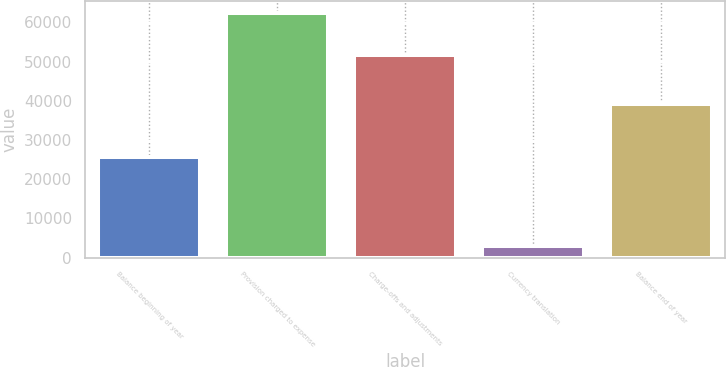Convert chart to OTSL. <chart><loc_0><loc_0><loc_500><loc_500><bar_chart><fcel>Balance beginning of year<fcel>Provision charged to expense<fcel>Charge-offs and adjustments<fcel>Currency translation<fcel>Balance end of year<nl><fcel>25565<fcel>62316<fcel>51652<fcel>3053<fcel>39282<nl></chart> 